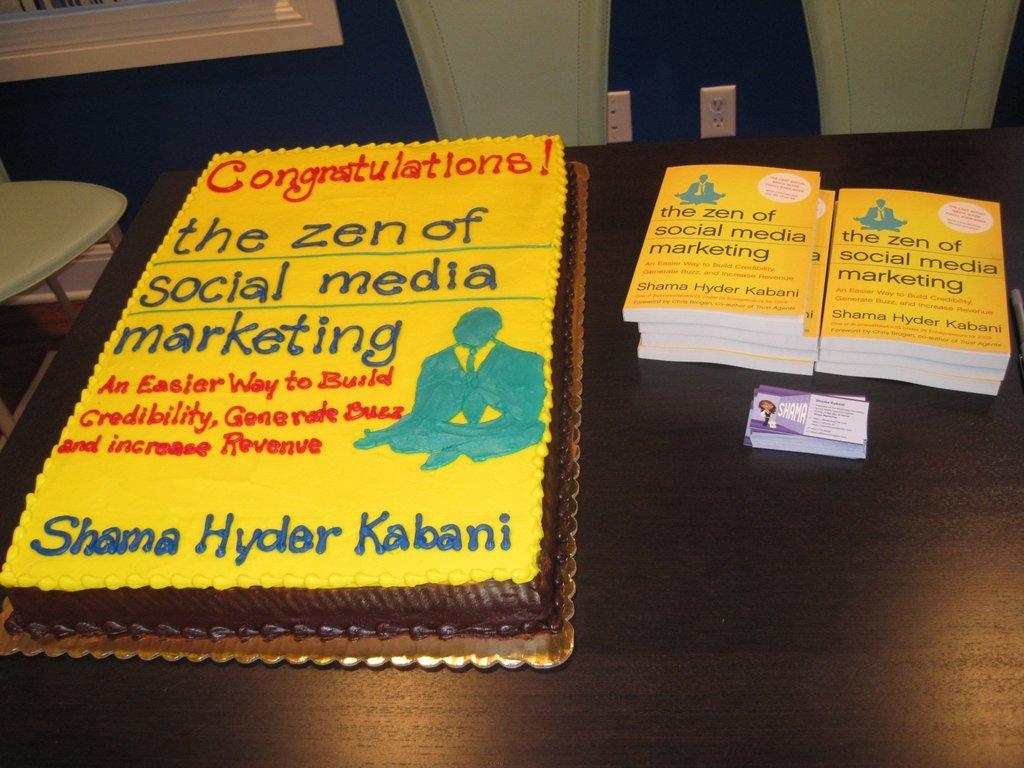Could you give a brief overview of what you see in this image? In this image there is one table and on the table there is one cake and books are there, and in the top of the image there is one wall and some switch boards are there. On the top of the left corner there is one window. In the middle of the left there is one table. 